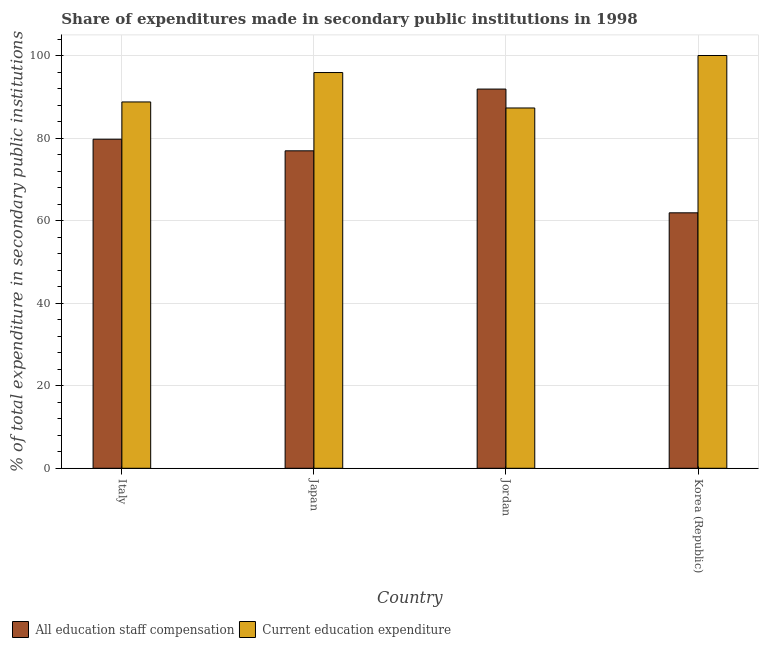How many different coloured bars are there?
Give a very brief answer. 2. How many groups of bars are there?
Ensure brevity in your answer.  4. Are the number of bars per tick equal to the number of legend labels?
Keep it short and to the point. Yes. Are the number of bars on each tick of the X-axis equal?
Make the answer very short. Yes. How many bars are there on the 2nd tick from the left?
Offer a terse response. 2. What is the label of the 4th group of bars from the left?
Offer a very short reply. Korea (Republic). What is the expenditure in staff compensation in Korea (Republic)?
Ensure brevity in your answer.  61.89. Across all countries, what is the maximum expenditure in staff compensation?
Provide a short and direct response. 91.87. Across all countries, what is the minimum expenditure in education?
Provide a short and direct response. 87.29. In which country was the expenditure in staff compensation maximum?
Make the answer very short. Jordan. What is the total expenditure in staff compensation in the graph?
Your response must be concise. 310.39. What is the difference between the expenditure in staff compensation in Italy and that in Japan?
Ensure brevity in your answer.  2.81. What is the difference between the expenditure in staff compensation in Japan and the expenditure in education in Jordan?
Offer a very short reply. -10.38. What is the average expenditure in education per country?
Your answer should be very brief. 92.98. What is the difference between the expenditure in education and expenditure in staff compensation in Korea (Republic)?
Provide a short and direct response. 38.11. In how many countries, is the expenditure in staff compensation greater than 92 %?
Provide a short and direct response. 0. What is the ratio of the expenditure in education in Italy to that in Japan?
Your answer should be very brief. 0.93. What is the difference between the highest and the second highest expenditure in staff compensation?
Your answer should be very brief. 12.15. What is the difference between the highest and the lowest expenditure in education?
Give a very brief answer. 12.71. In how many countries, is the expenditure in staff compensation greater than the average expenditure in staff compensation taken over all countries?
Your answer should be very brief. 2. What does the 1st bar from the left in Jordan represents?
Your answer should be very brief. All education staff compensation. What does the 2nd bar from the right in Japan represents?
Make the answer very short. All education staff compensation. How many bars are there?
Offer a very short reply. 8. Are all the bars in the graph horizontal?
Your answer should be very brief. No. What is the difference between two consecutive major ticks on the Y-axis?
Your answer should be very brief. 20. Does the graph contain grids?
Make the answer very short. Yes. How are the legend labels stacked?
Provide a short and direct response. Horizontal. What is the title of the graph?
Provide a short and direct response. Share of expenditures made in secondary public institutions in 1998. Does "Broad money growth" appear as one of the legend labels in the graph?
Your answer should be compact. No. What is the label or title of the Y-axis?
Offer a very short reply. % of total expenditure in secondary public institutions. What is the % of total expenditure in secondary public institutions of All education staff compensation in Italy?
Make the answer very short. 79.72. What is the % of total expenditure in secondary public institutions of Current education expenditure in Italy?
Your response must be concise. 88.75. What is the % of total expenditure in secondary public institutions in All education staff compensation in Japan?
Make the answer very short. 76.91. What is the % of total expenditure in secondary public institutions of Current education expenditure in Japan?
Ensure brevity in your answer.  95.87. What is the % of total expenditure in secondary public institutions of All education staff compensation in Jordan?
Make the answer very short. 91.87. What is the % of total expenditure in secondary public institutions of Current education expenditure in Jordan?
Keep it short and to the point. 87.29. What is the % of total expenditure in secondary public institutions of All education staff compensation in Korea (Republic)?
Provide a succinct answer. 61.89. Across all countries, what is the maximum % of total expenditure in secondary public institutions of All education staff compensation?
Your answer should be compact. 91.87. Across all countries, what is the maximum % of total expenditure in secondary public institutions of Current education expenditure?
Ensure brevity in your answer.  100. Across all countries, what is the minimum % of total expenditure in secondary public institutions of All education staff compensation?
Offer a terse response. 61.89. Across all countries, what is the minimum % of total expenditure in secondary public institutions in Current education expenditure?
Make the answer very short. 87.29. What is the total % of total expenditure in secondary public institutions of All education staff compensation in the graph?
Provide a succinct answer. 310.39. What is the total % of total expenditure in secondary public institutions of Current education expenditure in the graph?
Your answer should be very brief. 371.91. What is the difference between the % of total expenditure in secondary public institutions of All education staff compensation in Italy and that in Japan?
Provide a short and direct response. 2.81. What is the difference between the % of total expenditure in secondary public institutions in Current education expenditure in Italy and that in Japan?
Give a very brief answer. -7.12. What is the difference between the % of total expenditure in secondary public institutions of All education staff compensation in Italy and that in Jordan?
Offer a very short reply. -12.15. What is the difference between the % of total expenditure in secondary public institutions of Current education expenditure in Italy and that in Jordan?
Your answer should be very brief. 1.46. What is the difference between the % of total expenditure in secondary public institutions of All education staff compensation in Italy and that in Korea (Republic)?
Provide a succinct answer. 17.83. What is the difference between the % of total expenditure in secondary public institutions in Current education expenditure in Italy and that in Korea (Republic)?
Your answer should be compact. -11.25. What is the difference between the % of total expenditure in secondary public institutions in All education staff compensation in Japan and that in Jordan?
Provide a short and direct response. -14.96. What is the difference between the % of total expenditure in secondary public institutions of Current education expenditure in Japan and that in Jordan?
Offer a very short reply. 8.58. What is the difference between the % of total expenditure in secondary public institutions of All education staff compensation in Japan and that in Korea (Republic)?
Keep it short and to the point. 15.02. What is the difference between the % of total expenditure in secondary public institutions in Current education expenditure in Japan and that in Korea (Republic)?
Offer a very short reply. -4.13. What is the difference between the % of total expenditure in secondary public institutions in All education staff compensation in Jordan and that in Korea (Republic)?
Give a very brief answer. 29.98. What is the difference between the % of total expenditure in secondary public institutions in Current education expenditure in Jordan and that in Korea (Republic)?
Make the answer very short. -12.71. What is the difference between the % of total expenditure in secondary public institutions in All education staff compensation in Italy and the % of total expenditure in secondary public institutions in Current education expenditure in Japan?
Make the answer very short. -16.15. What is the difference between the % of total expenditure in secondary public institutions in All education staff compensation in Italy and the % of total expenditure in secondary public institutions in Current education expenditure in Jordan?
Provide a short and direct response. -7.57. What is the difference between the % of total expenditure in secondary public institutions of All education staff compensation in Italy and the % of total expenditure in secondary public institutions of Current education expenditure in Korea (Republic)?
Give a very brief answer. -20.28. What is the difference between the % of total expenditure in secondary public institutions of All education staff compensation in Japan and the % of total expenditure in secondary public institutions of Current education expenditure in Jordan?
Your answer should be compact. -10.38. What is the difference between the % of total expenditure in secondary public institutions in All education staff compensation in Japan and the % of total expenditure in secondary public institutions in Current education expenditure in Korea (Republic)?
Offer a very short reply. -23.09. What is the difference between the % of total expenditure in secondary public institutions in All education staff compensation in Jordan and the % of total expenditure in secondary public institutions in Current education expenditure in Korea (Republic)?
Your answer should be very brief. -8.13. What is the average % of total expenditure in secondary public institutions of All education staff compensation per country?
Your answer should be compact. 77.6. What is the average % of total expenditure in secondary public institutions of Current education expenditure per country?
Your response must be concise. 92.98. What is the difference between the % of total expenditure in secondary public institutions of All education staff compensation and % of total expenditure in secondary public institutions of Current education expenditure in Italy?
Your answer should be compact. -9.03. What is the difference between the % of total expenditure in secondary public institutions of All education staff compensation and % of total expenditure in secondary public institutions of Current education expenditure in Japan?
Offer a very short reply. -18.96. What is the difference between the % of total expenditure in secondary public institutions in All education staff compensation and % of total expenditure in secondary public institutions in Current education expenditure in Jordan?
Keep it short and to the point. 4.58. What is the difference between the % of total expenditure in secondary public institutions in All education staff compensation and % of total expenditure in secondary public institutions in Current education expenditure in Korea (Republic)?
Give a very brief answer. -38.11. What is the ratio of the % of total expenditure in secondary public institutions of All education staff compensation in Italy to that in Japan?
Your response must be concise. 1.04. What is the ratio of the % of total expenditure in secondary public institutions in Current education expenditure in Italy to that in Japan?
Your response must be concise. 0.93. What is the ratio of the % of total expenditure in secondary public institutions in All education staff compensation in Italy to that in Jordan?
Your answer should be compact. 0.87. What is the ratio of the % of total expenditure in secondary public institutions of Current education expenditure in Italy to that in Jordan?
Your response must be concise. 1.02. What is the ratio of the % of total expenditure in secondary public institutions in All education staff compensation in Italy to that in Korea (Republic)?
Your answer should be compact. 1.29. What is the ratio of the % of total expenditure in secondary public institutions of Current education expenditure in Italy to that in Korea (Republic)?
Offer a terse response. 0.89. What is the ratio of the % of total expenditure in secondary public institutions in All education staff compensation in Japan to that in Jordan?
Keep it short and to the point. 0.84. What is the ratio of the % of total expenditure in secondary public institutions of Current education expenditure in Japan to that in Jordan?
Provide a succinct answer. 1.1. What is the ratio of the % of total expenditure in secondary public institutions in All education staff compensation in Japan to that in Korea (Republic)?
Your response must be concise. 1.24. What is the ratio of the % of total expenditure in secondary public institutions of Current education expenditure in Japan to that in Korea (Republic)?
Provide a succinct answer. 0.96. What is the ratio of the % of total expenditure in secondary public institutions of All education staff compensation in Jordan to that in Korea (Republic)?
Give a very brief answer. 1.48. What is the ratio of the % of total expenditure in secondary public institutions in Current education expenditure in Jordan to that in Korea (Republic)?
Your answer should be compact. 0.87. What is the difference between the highest and the second highest % of total expenditure in secondary public institutions of All education staff compensation?
Provide a short and direct response. 12.15. What is the difference between the highest and the second highest % of total expenditure in secondary public institutions in Current education expenditure?
Keep it short and to the point. 4.13. What is the difference between the highest and the lowest % of total expenditure in secondary public institutions of All education staff compensation?
Ensure brevity in your answer.  29.98. What is the difference between the highest and the lowest % of total expenditure in secondary public institutions in Current education expenditure?
Your response must be concise. 12.71. 